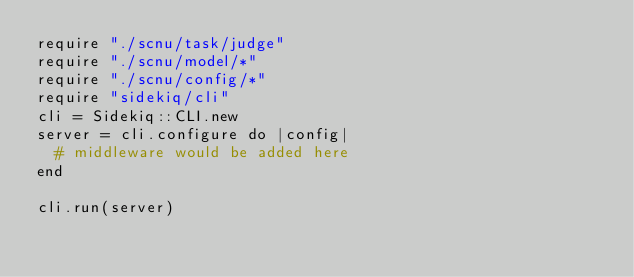Convert code to text. <code><loc_0><loc_0><loc_500><loc_500><_Crystal_>require "./scnu/task/judge"
require "./scnu/model/*"
require "./scnu/config/*"
require "sidekiq/cli"
cli = Sidekiq::CLI.new
server = cli.configure do |config|
  # middleware would be added here
end

cli.run(server)
</code> 